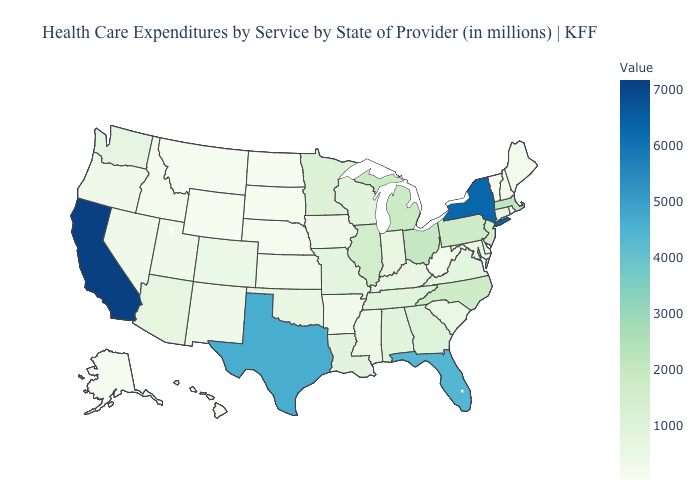Does Georgia have a lower value than Idaho?
Be succinct. No. Among the states that border Minnesota , does South Dakota have the lowest value?
Keep it brief. Yes. Does Washington have a lower value than New York?
Answer briefly. Yes. Among the states that border Pennsylvania , which have the highest value?
Keep it brief. New York. Which states hav the highest value in the South?
Give a very brief answer. Texas. Which states have the lowest value in the South?
Give a very brief answer. Delaware. 